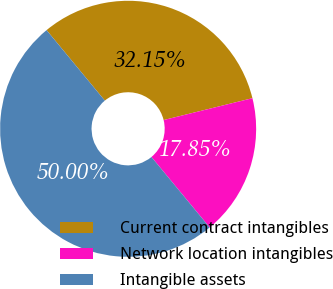<chart> <loc_0><loc_0><loc_500><loc_500><pie_chart><fcel>Current contract intangibles<fcel>Network location intangibles<fcel>Intangible assets<nl><fcel>32.15%<fcel>17.85%<fcel>50.0%<nl></chart> 